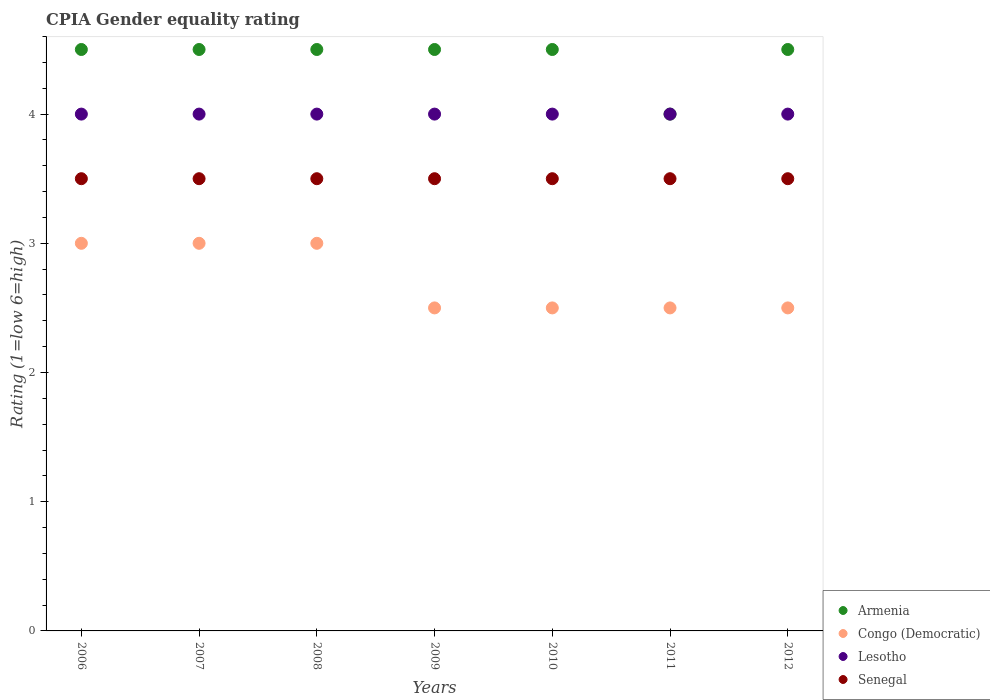Across all years, what is the maximum CPIA rating in Congo (Democratic)?
Your answer should be compact. 3. Across all years, what is the minimum CPIA rating in Congo (Democratic)?
Offer a very short reply. 2.5. What is the total CPIA rating in Lesotho in the graph?
Give a very brief answer. 28. In how many years, is the CPIA rating in Armenia greater than 3.6?
Your response must be concise. 7. Is the CPIA rating in Lesotho in 2009 less than that in 2010?
Your response must be concise. No. Is the difference between the CPIA rating in Lesotho in 2008 and 2011 greater than the difference between the CPIA rating in Senegal in 2008 and 2011?
Ensure brevity in your answer.  No. What is the difference between the highest and the second highest CPIA rating in Lesotho?
Your answer should be very brief. 0. What is the difference between the highest and the lowest CPIA rating in Armenia?
Offer a very short reply. 0.5. In how many years, is the CPIA rating in Lesotho greater than the average CPIA rating in Lesotho taken over all years?
Ensure brevity in your answer.  0. Is it the case that in every year, the sum of the CPIA rating in Lesotho and CPIA rating in Senegal  is greater than the CPIA rating in Armenia?
Provide a short and direct response. Yes. Does the CPIA rating in Armenia monotonically increase over the years?
Give a very brief answer. No. Is the CPIA rating in Congo (Democratic) strictly less than the CPIA rating in Senegal over the years?
Provide a short and direct response. Yes. How many dotlines are there?
Your response must be concise. 4. Does the graph contain any zero values?
Your response must be concise. No. How many legend labels are there?
Keep it short and to the point. 4. What is the title of the graph?
Offer a terse response. CPIA Gender equality rating. What is the label or title of the X-axis?
Your answer should be compact. Years. What is the Rating (1=low 6=high) of Congo (Democratic) in 2006?
Ensure brevity in your answer.  3. What is the Rating (1=low 6=high) of Senegal in 2006?
Make the answer very short. 3.5. What is the Rating (1=low 6=high) of Armenia in 2007?
Offer a very short reply. 4.5. What is the Rating (1=low 6=high) in Congo (Democratic) in 2007?
Offer a terse response. 3. What is the Rating (1=low 6=high) in Lesotho in 2007?
Your answer should be very brief. 4. What is the Rating (1=low 6=high) in Armenia in 2008?
Your response must be concise. 4.5. What is the Rating (1=low 6=high) of Congo (Democratic) in 2008?
Your answer should be compact. 3. What is the Rating (1=low 6=high) of Senegal in 2008?
Your answer should be very brief. 3.5. What is the Rating (1=low 6=high) in Congo (Democratic) in 2009?
Give a very brief answer. 2.5. What is the Rating (1=low 6=high) of Lesotho in 2009?
Ensure brevity in your answer.  4. What is the Rating (1=low 6=high) in Lesotho in 2010?
Provide a short and direct response. 4. What is the Rating (1=low 6=high) of Armenia in 2011?
Offer a terse response. 4. What is the Rating (1=low 6=high) in Congo (Democratic) in 2011?
Your answer should be very brief. 2.5. What is the Rating (1=low 6=high) of Senegal in 2011?
Offer a very short reply. 3.5. What is the Rating (1=low 6=high) of Lesotho in 2012?
Offer a very short reply. 4. Across all years, what is the maximum Rating (1=low 6=high) in Senegal?
Your response must be concise. 3.5. Across all years, what is the minimum Rating (1=low 6=high) in Armenia?
Make the answer very short. 4. Across all years, what is the minimum Rating (1=low 6=high) in Congo (Democratic)?
Give a very brief answer. 2.5. Across all years, what is the minimum Rating (1=low 6=high) of Senegal?
Make the answer very short. 3.5. What is the total Rating (1=low 6=high) in Armenia in the graph?
Offer a terse response. 31. What is the total Rating (1=low 6=high) of Congo (Democratic) in the graph?
Your answer should be compact. 19. What is the total Rating (1=low 6=high) of Senegal in the graph?
Provide a short and direct response. 24.5. What is the difference between the Rating (1=low 6=high) in Armenia in 2006 and that in 2007?
Offer a terse response. 0. What is the difference between the Rating (1=low 6=high) in Lesotho in 2006 and that in 2007?
Give a very brief answer. 0. What is the difference between the Rating (1=low 6=high) in Congo (Democratic) in 2006 and that in 2008?
Your answer should be compact. 0. What is the difference between the Rating (1=low 6=high) of Lesotho in 2006 and that in 2008?
Make the answer very short. 0. What is the difference between the Rating (1=low 6=high) in Senegal in 2006 and that in 2008?
Your response must be concise. 0. What is the difference between the Rating (1=low 6=high) of Armenia in 2006 and that in 2009?
Provide a short and direct response. 0. What is the difference between the Rating (1=low 6=high) in Congo (Democratic) in 2006 and that in 2009?
Offer a very short reply. 0.5. What is the difference between the Rating (1=low 6=high) in Senegal in 2006 and that in 2009?
Make the answer very short. 0. What is the difference between the Rating (1=low 6=high) of Armenia in 2006 and that in 2010?
Offer a very short reply. 0. What is the difference between the Rating (1=low 6=high) of Lesotho in 2006 and that in 2010?
Offer a very short reply. 0. What is the difference between the Rating (1=low 6=high) in Senegal in 2006 and that in 2010?
Offer a terse response. 0. What is the difference between the Rating (1=low 6=high) of Armenia in 2006 and that in 2011?
Your response must be concise. 0.5. What is the difference between the Rating (1=low 6=high) in Senegal in 2006 and that in 2011?
Provide a short and direct response. 0. What is the difference between the Rating (1=low 6=high) in Congo (Democratic) in 2006 and that in 2012?
Provide a short and direct response. 0.5. What is the difference between the Rating (1=low 6=high) in Lesotho in 2006 and that in 2012?
Offer a very short reply. 0. What is the difference between the Rating (1=low 6=high) of Senegal in 2006 and that in 2012?
Provide a succinct answer. 0. What is the difference between the Rating (1=low 6=high) of Armenia in 2007 and that in 2008?
Provide a succinct answer. 0. What is the difference between the Rating (1=low 6=high) of Congo (Democratic) in 2007 and that in 2008?
Provide a succinct answer. 0. What is the difference between the Rating (1=low 6=high) in Lesotho in 2007 and that in 2008?
Offer a very short reply. 0. What is the difference between the Rating (1=low 6=high) of Armenia in 2007 and that in 2009?
Offer a terse response. 0. What is the difference between the Rating (1=low 6=high) in Congo (Democratic) in 2007 and that in 2009?
Keep it short and to the point. 0.5. What is the difference between the Rating (1=low 6=high) in Senegal in 2007 and that in 2009?
Make the answer very short. 0. What is the difference between the Rating (1=low 6=high) of Armenia in 2007 and that in 2010?
Ensure brevity in your answer.  0. What is the difference between the Rating (1=low 6=high) of Congo (Democratic) in 2007 and that in 2010?
Your answer should be compact. 0.5. What is the difference between the Rating (1=low 6=high) in Senegal in 2007 and that in 2011?
Offer a very short reply. 0. What is the difference between the Rating (1=low 6=high) of Lesotho in 2007 and that in 2012?
Ensure brevity in your answer.  0. What is the difference between the Rating (1=low 6=high) in Senegal in 2007 and that in 2012?
Your answer should be very brief. 0. What is the difference between the Rating (1=low 6=high) of Congo (Democratic) in 2008 and that in 2009?
Your answer should be very brief. 0.5. What is the difference between the Rating (1=low 6=high) of Senegal in 2008 and that in 2009?
Offer a terse response. 0. What is the difference between the Rating (1=low 6=high) of Senegal in 2008 and that in 2010?
Your answer should be compact. 0. What is the difference between the Rating (1=low 6=high) of Congo (Democratic) in 2008 and that in 2011?
Make the answer very short. 0.5. What is the difference between the Rating (1=low 6=high) in Senegal in 2008 and that in 2011?
Your answer should be very brief. 0. What is the difference between the Rating (1=low 6=high) in Congo (Democratic) in 2008 and that in 2012?
Your answer should be compact. 0.5. What is the difference between the Rating (1=low 6=high) of Lesotho in 2008 and that in 2012?
Offer a very short reply. 0. What is the difference between the Rating (1=low 6=high) in Congo (Democratic) in 2009 and that in 2010?
Offer a very short reply. 0. What is the difference between the Rating (1=low 6=high) in Lesotho in 2009 and that in 2010?
Keep it short and to the point. 0. What is the difference between the Rating (1=low 6=high) of Armenia in 2009 and that in 2011?
Provide a succinct answer. 0.5. What is the difference between the Rating (1=low 6=high) of Lesotho in 2009 and that in 2011?
Offer a terse response. 0. What is the difference between the Rating (1=low 6=high) in Congo (Democratic) in 2009 and that in 2012?
Your answer should be very brief. 0. What is the difference between the Rating (1=low 6=high) of Congo (Democratic) in 2010 and that in 2011?
Make the answer very short. 0. What is the difference between the Rating (1=low 6=high) in Senegal in 2010 and that in 2011?
Your response must be concise. 0. What is the difference between the Rating (1=low 6=high) of Senegal in 2010 and that in 2012?
Give a very brief answer. 0. What is the difference between the Rating (1=low 6=high) in Armenia in 2011 and that in 2012?
Provide a short and direct response. -0.5. What is the difference between the Rating (1=low 6=high) in Senegal in 2011 and that in 2012?
Provide a succinct answer. 0. What is the difference between the Rating (1=low 6=high) of Congo (Democratic) in 2006 and the Rating (1=low 6=high) of Senegal in 2007?
Make the answer very short. -0.5. What is the difference between the Rating (1=low 6=high) in Armenia in 2006 and the Rating (1=low 6=high) in Lesotho in 2008?
Ensure brevity in your answer.  0.5. What is the difference between the Rating (1=low 6=high) in Congo (Democratic) in 2006 and the Rating (1=low 6=high) in Senegal in 2008?
Your response must be concise. -0.5. What is the difference between the Rating (1=low 6=high) of Lesotho in 2006 and the Rating (1=low 6=high) of Senegal in 2008?
Give a very brief answer. 0.5. What is the difference between the Rating (1=low 6=high) of Armenia in 2006 and the Rating (1=low 6=high) of Congo (Democratic) in 2009?
Give a very brief answer. 2. What is the difference between the Rating (1=low 6=high) in Armenia in 2006 and the Rating (1=low 6=high) in Senegal in 2009?
Provide a succinct answer. 1. What is the difference between the Rating (1=low 6=high) in Congo (Democratic) in 2006 and the Rating (1=low 6=high) in Lesotho in 2009?
Your response must be concise. -1. What is the difference between the Rating (1=low 6=high) of Armenia in 2006 and the Rating (1=low 6=high) of Senegal in 2010?
Offer a terse response. 1. What is the difference between the Rating (1=low 6=high) of Armenia in 2006 and the Rating (1=low 6=high) of Congo (Democratic) in 2012?
Keep it short and to the point. 2. What is the difference between the Rating (1=low 6=high) of Armenia in 2006 and the Rating (1=low 6=high) of Lesotho in 2012?
Your answer should be compact. 0.5. What is the difference between the Rating (1=low 6=high) in Armenia in 2006 and the Rating (1=low 6=high) in Senegal in 2012?
Your answer should be very brief. 1. What is the difference between the Rating (1=low 6=high) of Congo (Democratic) in 2006 and the Rating (1=low 6=high) of Senegal in 2012?
Provide a succinct answer. -0.5. What is the difference between the Rating (1=low 6=high) in Lesotho in 2006 and the Rating (1=low 6=high) in Senegal in 2012?
Provide a succinct answer. 0.5. What is the difference between the Rating (1=low 6=high) in Congo (Democratic) in 2007 and the Rating (1=low 6=high) in Lesotho in 2008?
Your answer should be compact. -1. What is the difference between the Rating (1=low 6=high) in Congo (Democratic) in 2007 and the Rating (1=low 6=high) in Senegal in 2008?
Offer a very short reply. -0.5. What is the difference between the Rating (1=low 6=high) of Armenia in 2007 and the Rating (1=low 6=high) of Lesotho in 2009?
Provide a short and direct response. 0.5. What is the difference between the Rating (1=low 6=high) of Lesotho in 2007 and the Rating (1=low 6=high) of Senegal in 2009?
Keep it short and to the point. 0.5. What is the difference between the Rating (1=low 6=high) in Armenia in 2007 and the Rating (1=low 6=high) in Lesotho in 2010?
Ensure brevity in your answer.  0.5. What is the difference between the Rating (1=low 6=high) of Congo (Democratic) in 2007 and the Rating (1=low 6=high) of Lesotho in 2010?
Ensure brevity in your answer.  -1. What is the difference between the Rating (1=low 6=high) of Armenia in 2007 and the Rating (1=low 6=high) of Senegal in 2011?
Make the answer very short. 1. What is the difference between the Rating (1=low 6=high) in Congo (Democratic) in 2007 and the Rating (1=low 6=high) in Lesotho in 2011?
Make the answer very short. -1. What is the difference between the Rating (1=low 6=high) of Congo (Democratic) in 2007 and the Rating (1=low 6=high) of Senegal in 2011?
Offer a very short reply. -0.5. What is the difference between the Rating (1=low 6=high) in Armenia in 2007 and the Rating (1=low 6=high) in Congo (Democratic) in 2012?
Keep it short and to the point. 2. What is the difference between the Rating (1=low 6=high) of Congo (Democratic) in 2007 and the Rating (1=low 6=high) of Lesotho in 2012?
Keep it short and to the point. -1. What is the difference between the Rating (1=low 6=high) in Congo (Democratic) in 2007 and the Rating (1=low 6=high) in Senegal in 2012?
Offer a very short reply. -0.5. What is the difference between the Rating (1=low 6=high) in Lesotho in 2007 and the Rating (1=low 6=high) in Senegal in 2012?
Give a very brief answer. 0.5. What is the difference between the Rating (1=low 6=high) of Congo (Democratic) in 2008 and the Rating (1=low 6=high) of Lesotho in 2009?
Provide a short and direct response. -1. What is the difference between the Rating (1=low 6=high) of Congo (Democratic) in 2008 and the Rating (1=low 6=high) of Senegal in 2009?
Give a very brief answer. -0.5. What is the difference between the Rating (1=low 6=high) in Lesotho in 2008 and the Rating (1=low 6=high) in Senegal in 2009?
Your answer should be very brief. 0.5. What is the difference between the Rating (1=low 6=high) of Armenia in 2008 and the Rating (1=low 6=high) of Senegal in 2010?
Give a very brief answer. 1. What is the difference between the Rating (1=low 6=high) in Congo (Democratic) in 2008 and the Rating (1=low 6=high) in Senegal in 2010?
Offer a terse response. -0.5. What is the difference between the Rating (1=low 6=high) of Lesotho in 2008 and the Rating (1=low 6=high) of Senegal in 2010?
Provide a succinct answer. 0.5. What is the difference between the Rating (1=low 6=high) in Armenia in 2008 and the Rating (1=low 6=high) in Senegal in 2011?
Give a very brief answer. 1. What is the difference between the Rating (1=low 6=high) of Congo (Democratic) in 2008 and the Rating (1=low 6=high) of Senegal in 2011?
Offer a very short reply. -0.5. What is the difference between the Rating (1=low 6=high) in Lesotho in 2008 and the Rating (1=low 6=high) in Senegal in 2011?
Give a very brief answer. 0.5. What is the difference between the Rating (1=low 6=high) of Congo (Democratic) in 2008 and the Rating (1=low 6=high) of Lesotho in 2012?
Your response must be concise. -1. What is the difference between the Rating (1=low 6=high) in Congo (Democratic) in 2008 and the Rating (1=low 6=high) in Senegal in 2012?
Your response must be concise. -0.5. What is the difference between the Rating (1=low 6=high) in Lesotho in 2008 and the Rating (1=low 6=high) in Senegal in 2012?
Give a very brief answer. 0.5. What is the difference between the Rating (1=low 6=high) in Armenia in 2009 and the Rating (1=low 6=high) in Lesotho in 2010?
Make the answer very short. 0.5. What is the difference between the Rating (1=low 6=high) of Armenia in 2009 and the Rating (1=low 6=high) of Senegal in 2010?
Keep it short and to the point. 1. What is the difference between the Rating (1=low 6=high) in Armenia in 2009 and the Rating (1=low 6=high) in Senegal in 2011?
Make the answer very short. 1. What is the difference between the Rating (1=low 6=high) of Lesotho in 2009 and the Rating (1=low 6=high) of Senegal in 2011?
Ensure brevity in your answer.  0.5. What is the difference between the Rating (1=low 6=high) in Armenia in 2009 and the Rating (1=low 6=high) in Senegal in 2012?
Keep it short and to the point. 1. What is the difference between the Rating (1=low 6=high) in Congo (Democratic) in 2009 and the Rating (1=low 6=high) in Lesotho in 2012?
Provide a short and direct response. -1.5. What is the difference between the Rating (1=low 6=high) of Congo (Democratic) in 2009 and the Rating (1=low 6=high) of Senegal in 2012?
Keep it short and to the point. -1. What is the difference between the Rating (1=low 6=high) in Lesotho in 2009 and the Rating (1=low 6=high) in Senegal in 2012?
Provide a short and direct response. 0.5. What is the difference between the Rating (1=low 6=high) of Armenia in 2010 and the Rating (1=low 6=high) of Senegal in 2011?
Offer a terse response. 1. What is the difference between the Rating (1=low 6=high) in Congo (Democratic) in 2010 and the Rating (1=low 6=high) in Lesotho in 2011?
Ensure brevity in your answer.  -1.5. What is the difference between the Rating (1=low 6=high) in Lesotho in 2010 and the Rating (1=low 6=high) in Senegal in 2011?
Make the answer very short. 0.5. What is the difference between the Rating (1=low 6=high) in Armenia in 2010 and the Rating (1=low 6=high) in Congo (Democratic) in 2012?
Offer a very short reply. 2. What is the difference between the Rating (1=low 6=high) of Armenia in 2010 and the Rating (1=low 6=high) of Senegal in 2012?
Give a very brief answer. 1. What is the difference between the Rating (1=low 6=high) in Congo (Democratic) in 2010 and the Rating (1=low 6=high) in Senegal in 2012?
Offer a terse response. -1. What is the difference between the Rating (1=low 6=high) in Lesotho in 2010 and the Rating (1=low 6=high) in Senegal in 2012?
Make the answer very short. 0.5. What is the difference between the Rating (1=low 6=high) of Armenia in 2011 and the Rating (1=low 6=high) of Congo (Democratic) in 2012?
Make the answer very short. 1.5. What is the difference between the Rating (1=low 6=high) of Armenia in 2011 and the Rating (1=low 6=high) of Lesotho in 2012?
Provide a short and direct response. 0. What is the difference between the Rating (1=low 6=high) of Congo (Democratic) in 2011 and the Rating (1=low 6=high) of Lesotho in 2012?
Provide a succinct answer. -1.5. What is the average Rating (1=low 6=high) in Armenia per year?
Offer a very short reply. 4.43. What is the average Rating (1=low 6=high) in Congo (Democratic) per year?
Offer a terse response. 2.71. What is the average Rating (1=low 6=high) in Lesotho per year?
Ensure brevity in your answer.  4. In the year 2006, what is the difference between the Rating (1=low 6=high) in Congo (Democratic) and Rating (1=low 6=high) in Lesotho?
Make the answer very short. -1. In the year 2006, what is the difference between the Rating (1=low 6=high) in Congo (Democratic) and Rating (1=low 6=high) in Senegal?
Your answer should be compact. -0.5. In the year 2006, what is the difference between the Rating (1=low 6=high) of Lesotho and Rating (1=low 6=high) of Senegal?
Keep it short and to the point. 0.5. In the year 2007, what is the difference between the Rating (1=low 6=high) of Armenia and Rating (1=low 6=high) of Congo (Democratic)?
Provide a short and direct response. 1.5. In the year 2007, what is the difference between the Rating (1=low 6=high) of Congo (Democratic) and Rating (1=low 6=high) of Lesotho?
Offer a very short reply. -1. In the year 2008, what is the difference between the Rating (1=low 6=high) of Armenia and Rating (1=low 6=high) of Lesotho?
Provide a succinct answer. 0.5. In the year 2008, what is the difference between the Rating (1=low 6=high) of Congo (Democratic) and Rating (1=low 6=high) of Senegal?
Keep it short and to the point. -0.5. In the year 2008, what is the difference between the Rating (1=low 6=high) in Lesotho and Rating (1=low 6=high) in Senegal?
Your response must be concise. 0.5. In the year 2009, what is the difference between the Rating (1=low 6=high) in Armenia and Rating (1=low 6=high) in Congo (Democratic)?
Provide a succinct answer. 2. In the year 2009, what is the difference between the Rating (1=low 6=high) of Congo (Democratic) and Rating (1=low 6=high) of Senegal?
Provide a short and direct response. -1. In the year 2010, what is the difference between the Rating (1=low 6=high) of Armenia and Rating (1=low 6=high) of Lesotho?
Give a very brief answer. 0.5. In the year 2010, what is the difference between the Rating (1=low 6=high) of Armenia and Rating (1=low 6=high) of Senegal?
Your response must be concise. 1. In the year 2011, what is the difference between the Rating (1=low 6=high) of Armenia and Rating (1=low 6=high) of Congo (Democratic)?
Give a very brief answer. 1.5. In the year 2011, what is the difference between the Rating (1=low 6=high) of Armenia and Rating (1=low 6=high) of Lesotho?
Give a very brief answer. 0. In the year 2011, what is the difference between the Rating (1=low 6=high) in Armenia and Rating (1=low 6=high) in Senegal?
Provide a short and direct response. 0.5. In the year 2011, what is the difference between the Rating (1=low 6=high) of Lesotho and Rating (1=low 6=high) of Senegal?
Offer a very short reply. 0.5. In the year 2012, what is the difference between the Rating (1=low 6=high) in Armenia and Rating (1=low 6=high) in Senegal?
Ensure brevity in your answer.  1. In the year 2012, what is the difference between the Rating (1=low 6=high) of Congo (Democratic) and Rating (1=low 6=high) of Senegal?
Your response must be concise. -1. In the year 2012, what is the difference between the Rating (1=low 6=high) of Lesotho and Rating (1=low 6=high) of Senegal?
Your response must be concise. 0.5. What is the ratio of the Rating (1=low 6=high) in Armenia in 2006 to that in 2007?
Ensure brevity in your answer.  1. What is the ratio of the Rating (1=low 6=high) in Congo (Democratic) in 2006 to that in 2007?
Your answer should be very brief. 1. What is the ratio of the Rating (1=low 6=high) in Armenia in 2006 to that in 2008?
Your response must be concise. 1. What is the ratio of the Rating (1=low 6=high) in Armenia in 2006 to that in 2009?
Keep it short and to the point. 1. What is the ratio of the Rating (1=low 6=high) of Lesotho in 2006 to that in 2009?
Make the answer very short. 1. What is the ratio of the Rating (1=low 6=high) in Congo (Democratic) in 2006 to that in 2010?
Your response must be concise. 1.2. What is the ratio of the Rating (1=low 6=high) in Senegal in 2006 to that in 2010?
Keep it short and to the point. 1. What is the ratio of the Rating (1=low 6=high) of Congo (Democratic) in 2006 to that in 2011?
Your response must be concise. 1.2. What is the ratio of the Rating (1=low 6=high) in Lesotho in 2006 to that in 2011?
Your response must be concise. 1. What is the ratio of the Rating (1=low 6=high) of Armenia in 2006 to that in 2012?
Give a very brief answer. 1. What is the ratio of the Rating (1=low 6=high) of Congo (Democratic) in 2006 to that in 2012?
Make the answer very short. 1.2. What is the ratio of the Rating (1=low 6=high) of Senegal in 2006 to that in 2012?
Ensure brevity in your answer.  1. What is the ratio of the Rating (1=low 6=high) in Armenia in 2007 to that in 2008?
Offer a terse response. 1. What is the ratio of the Rating (1=low 6=high) in Congo (Democratic) in 2007 to that in 2008?
Your response must be concise. 1. What is the ratio of the Rating (1=low 6=high) in Lesotho in 2007 to that in 2008?
Offer a terse response. 1. What is the ratio of the Rating (1=low 6=high) in Armenia in 2007 to that in 2009?
Ensure brevity in your answer.  1. What is the ratio of the Rating (1=low 6=high) in Senegal in 2007 to that in 2010?
Provide a succinct answer. 1. What is the ratio of the Rating (1=low 6=high) in Armenia in 2007 to that in 2011?
Give a very brief answer. 1.12. What is the ratio of the Rating (1=low 6=high) in Congo (Democratic) in 2007 to that in 2011?
Keep it short and to the point. 1.2. What is the ratio of the Rating (1=low 6=high) of Armenia in 2007 to that in 2012?
Offer a very short reply. 1. What is the ratio of the Rating (1=low 6=high) in Congo (Democratic) in 2007 to that in 2012?
Make the answer very short. 1.2. What is the ratio of the Rating (1=low 6=high) of Lesotho in 2007 to that in 2012?
Keep it short and to the point. 1. What is the ratio of the Rating (1=low 6=high) of Armenia in 2008 to that in 2010?
Give a very brief answer. 1. What is the ratio of the Rating (1=low 6=high) of Senegal in 2008 to that in 2010?
Ensure brevity in your answer.  1. What is the ratio of the Rating (1=low 6=high) in Armenia in 2008 to that in 2011?
Make the answer very short. 1.12. What is the ratio of the Rating (1=low 6=high) of Congo (Democratic) in 2008 to that in 2011?
Your answer should be compact. 1.2. What is the ratio of the Rating (1=low 6=high) in Senegal in 2008 to that in 2011?
Keep it short and to the point. 1. What is the ratio of the Rating (1=low 6=high) in Armenia in 2008 to that in 2012?
Ensure brevity in your answer.  1. What is the ratio of the Rating (1=low 6=high) of Senegal in 2008 to that in 2012?
Keep it short and to the point. 1. What is the ratio of the Rating (1=low 6=high) of Senegal in 2009 to that in 2010?
Your answer should be compact. 1. What is the ratio of the Rating (1=low 6=high) of Armenia in 2009 to that in 2011?
Your response must be concise. 1.12. What is the ratio of the Rating (1=low 6=high) of Senegal in 2009 to that in 2011?
Ensure brevity in your answer.  1. What is the ratio of the Rating (1=low 6=high) of Congo (Democratic) in 2009 to that in 2012?
Keep it short and to the point. 1. What is the ratio of the Rating (1=low 6=high) in Senegal in 2009 to that in 2012?
Your answer should be very brief. 1. What is the ratio of the Rating (1=low 6=high) of Armenia in 2010 to that in 2011?
Your answer should be very brief. 1.12. What is the ratio of the Rating (1=low 6=high) in Lesotho in 2010 to that in 2011?
Keep it short and to the point. 1. What is the ratio of the Rating (1=low 6=high) in Armenia in 2010 to that in 2012?
Ensure brevity in your answer.  1. What is the ratio of the Rating (1=low 6=high) in Lesotho in 2010 to that in 2012?
Your answer should be compact. 1. What is the ratio of the Rating (1=low 6=high) in Congo (Democratic) in 2011 to that in 2012?
Your answer should be very brief. 1. What is the ratio of the Rating (1=low 6=high) in Senegal in 2011 to that in 2012?
Your answer should be very brief. 1. What is the difference between the highest and the second highest Rating (1=low 6=high) of Congo (Democratic)?
Offer a terse response. 0. What is the difference between the highest and the second highest Rating (1=low 6=high) of Lesotho?
Offer a terse response. 0. What is the difference between the highest and the lowest Rating (1=low 6=high) of Armenia?
Your response must be concise. 0.5. What is the difference between the highest and the lowest Rating (1=low 6=high) of Congo (Democratic)?
Your response must be concise. 0.5. 